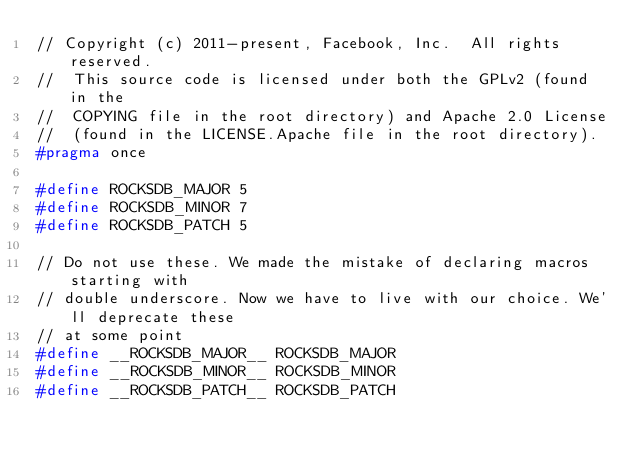Convert code to text. <code><loc_0><loc_0><loc_500><loc_500><_C_>// Copyright (c) 2011-present, Facebook, Inc.  All rights reserved.
//  This source code is licensed under both the GPLv2 (found in the
//  COPYING file in the root directory) and Apache 2.0 License
//  (found in the LICENSE.Apache file in the root directory).
#pragma once

#define ROCKSDB_MAJOR 5
#define ROCKSDB_MINOR 7
#define ROCKSDB_PATCH 5

// Do not use these. We made the mistake of declaring macros starting with
// double underscore. Now we have to live with our choice. We'll deprecate these
// at some point
#define __ROCKSDB_MAJOR__ ROCKSDB_MAJOR
#define __ROCKSDB_MINOR__ ROCKSDB_MINOR
#define __ROCKSDB_PATCH__ ROCKSDB_PATCH
</code> 